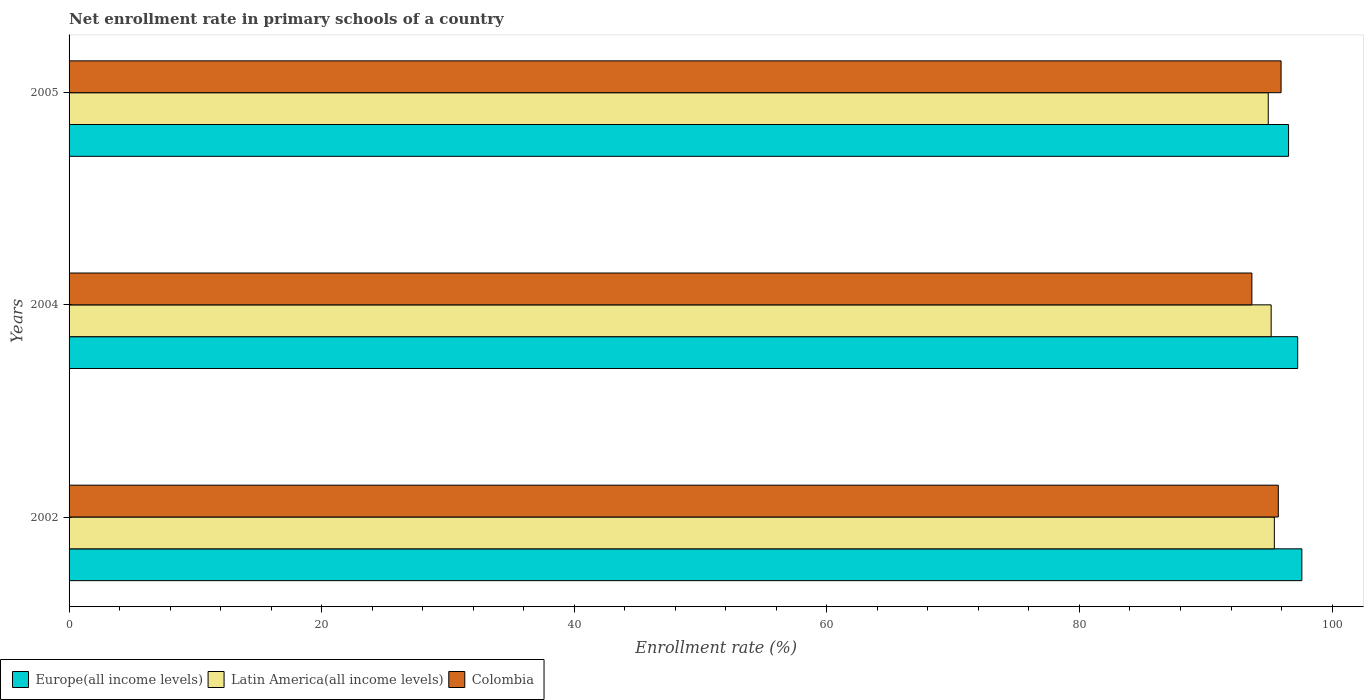How many different coloured bars are there?
Your answer should be compact. 3. Are the number of bars per tick equal to the number of legend labels?
Keep it short and to the point. Yes. How many bars are there on the 2nd tick from the bottom?
Your answer should be very brief. 3. What is the enrollment rate in primary schools in Europe(all income levels) in 2005?
Give a very brief answer. 96.56. Across all years, what is the maximum enrollment rate in primary schools in Europe(all income levels)?
Ensure brevity in your answer.  97.61. Across all years, what is the minimum enrollment rate in primary schools in Europe(all income levels)?
Keep it short and to the point. 96.56. In which year was the enrollment rate in primary schools in Latin America(all income levels) minimum?
Provide a succinct answer. 2005. What is the total enrollment rate in primary schools in Europe(all income levels) in the graph?
Your response must be concise. 291.44. What is the difference between the enrollment rate in primary schools in Colombia in 2004 and that in 2005?
Keep it short and to the point. -2.31. What is the difference between the enrollment rate in primary schools in Colombia in 2005 and the enrollment rate in primary schools in Latin America(all income levels) in 2002?
Give a very brief answer. 0.53. What is the average enrollment rate in primary schools in Europe(all income levels) per year?
Provide a short and direct response. 97.15. In the year 2002, what is the difference between the enrollment rate in primary schools in Europe(all income levels) and enrollment rate in primary schools in Colombia?
Make the answer very short. 1.86. What is the ratio of the enrollment rate in primary schools in Colombia in 2004 to that in 2005?
Make the answer very short. 0.98. Is the enrollment rate in primary schools in Latin America(all income levels) in 2002 less than that in 2004?
Keep it short and to the point. No. Is the difference between the enrollment rate in primary schools in Europe(all income levels) in 2002 and 2004 greater than the difference between the enrollment rate in primary schools in Colombia in 2002 and 2004?
Provide a succinct answer. No. What is the difference between the highest and the second highest enrollment rate in primary schools in Colombia?
Your response must be concise. 0.22. What is the difference between the highest and the lowest enrollment rate in primary schools in Europe(all income levels)?
Your answer should be very brief. 1.05. In how many years, is the enrollment rate in primary schools in Latin America(all income levels) greater than the average enrollment rate in primary schools in Latin America(all income levels) taken over all years?
Keep it short and to the point. 1. Is the sum of the enrollment rate in primary schools in Europe(all income levels) in 2002 and 2005 greater than the maximum enrollment rate in primary schools in Latin America(all income levels) across all years?
Ensure brevity in your answer.  Yes. What does the 1st bar from the top in 2004 represents?
Your response must be concise. Colombia. Is it the case that in every year, the sum of the enrollment rate in primary schools in Latin America(all income levels) and enrollment rate in primary schools in Europe(all income levels) is greater than the enrollment rate in primary schools in Colombia?
Keep it short and to the point. Yes. How many bars are there?
Offer a very short reply. 9. What is the difference between two consecutive major ticks on the X-axis?
Offer a terse response. 20. Are the values on the major ticks of X-axis written in scientific E-notation?
Ensure brevity in your answer.  No. How many legend labels are there?
Ensure brevity in your answer.  3. How are the legend labels stacked?
Provide a succinct answer. Horizontal. What is the title of the graph?
Give a very brief answer. Net enrollment rate in primary schools of a country. Does "Australia" appear as one of the legend labels in the graph?
Your response must be concise. No. What is the label or title of the X-axis?
Keep it short and to the point. Enrollment rate (%). What is the label or title of the Y-axis?
Offer a very short reply. Years. What is the Enrollment rate (%) of Europe(all income levels) in 2002?
Give a very brief answer. 97.61. What is the Enrollment rate (%) in Latin America(all income levels) in 2002?
Your answer should be very brief. 95.43. What is the Enrollment rate (%) in Colombia in 2002?
Provide a succinct answer. 95.74. What is the Enrollment rate (%) of Europe(all income levels) in 2004?
Ensure brevity in your answer.  97.28. What is the Enrollment rate (%) in Latin America(all income levels) in 2004?
Make the answer very short. 95.18. What is the Enrollment rate (%) in Colombia in 2004?
Give a very brief answer. 93.65. What is the Enrollment rate (%) of Europe(all income levels) in 2005?
Provide a succinct answer. 96.56. What is the Enrollment rate (%) of Latin America(all income levels) in 2005?
Your answer should be very brief. 94.95. What is the Enrollment rate (%) in Colombia in 2005?
Offer a very short reply. 95.96. Across all years, what is the maximum Enrollment rate (%) of Europe(all income levels)?
Your response must be concise. 97.61. Across all years, what is the maximum Enrollment rate (%) of Latin America(all income levels)?
Offer a terse response. 95.43. Across all years, what is the maximum Enrollment rate (%) of Colombia?
Your answer should be very brief. 95.96. Across all years, what is the minimum Enrollment rate (%) of Europe(all income levels)?
Make the answer very short. 96.56. Across all years, what is the minimum Enrollment rate (%) of Latin America(all income levels)?
Provide a succinct answer. 94.95. Across all years, what is the minimum Enrollment rate (%) in Colombia?
Your response must be concise. 93.65. What is the total Enrollment rate (%) in Europe(all income levels) in the graph?
Offer a very short reply. 291.44. What is the total Enrollment rate (%) in Latin America(all income levels) in the graph?
Offer a very short reply. 285.56. What is the total Enrollment rate (%) of Colombia in the graph?
Provide a short and direct response. 285.36. What is the difference between the Enrollment rate (%) in Europe(all income levels) in 2002 and that in 2004?
Provide a short and direct response. 0.33. What is the difference between the Enrollment rate (%) in Latin America(all income levels) in 2002 and that in 2004?
Give a very brief answer. 0.25. What is the difference between the Enrollment rate (%) in Colombia in 2002 and that in 2004?
Your response must be concise. 2.09. What is the difference between the Enrollment rate (%) in Europe(all income levels) in 2002 and that in 2005?
Provide a short and direct response. 1.05. What is the difference between the Enrollment rate (%) of Latin America(all income levels) in 2002 and that in 2005?
Offer a terse response. 0.48. What is the difference between the Enrollment rate (%) in Colombia in 2002 and that in 2005?
Ensure brevity in your answer.  -0.22. What is the difference between the Enrollment rate (%) in Europe(all income levels) in 2004 and that in 2005?
Ensure brevity in your answer.  0.72. What is the difference between the Enrollment rate (%) of Latin America(all income levels) in 2004 and that in 2005?
Your response must be concise. 0.23. What is the difference between the Enrollment rate (%) of Colombia in 2004 and that in 2005?
Your answer should be compact. -2.31. What is the difference between the Enrollment rate (%) of Europe(all income levels) in 2002 and the Enrollment rate (%) of Latin America(all income levels) in 2004?
Your answer should be very brief. 2.43. What is the difference between the Enrollment rate (%) of Europe(all income levels) in 2002 and the Enrollment rate (%) of Colombia in 2004?
Provide a short and direct response. 3.96. What is the difference between the Enrollment rate (%) in Latin America(all income levels) in 2002 and the Enrollment rate (%) in Colombia in 2004?
Make the answer very short. 1.78. What is the difference between the Enrollment rate (%) of Europe(all income levels) in 2002 and the Enrollment rate (%) of Latin America(all income levels) in 2005?
Provide a succinct answer. 2.66. What is the difference between the Enrollment rate (%) in Europe(all income levels) in 2002 and the Enrollment rate (%) in Colombia in 2005?
Give a very brief answer. 1.64. What is the difference between the Enrollment rate (%) in Latin America(all income levels) in 2002 and the Enrollment rate (%) in Colombia in 2005?
Your answer should be very brief. -0.53. What is the difference between the Enrollment rate (%) of Europe(all income levels) in 2004 and the Enrollment rate (%) of Latin America(all income levels) in 2005?
Provide a succinct answer. 2.33. What is the difference between the Enrollment rate (%) in Europe(all income levels) in 2004 and the Enrollment rate (%) in Colombia in 2005?
Offer a very short reply. 1.32. What is the difference between the Enrollment rate (%) of Latin America(all income levels) in 2004 and the Enrollment rate (%) of Colombia in 2005?
Your answer should be very brief. -0.79. What is the average Enrollment rate (%) of Europe(all income levels) per year?
Offer a very short reply. 97.15. What is the average Enrollment rate (%) of Latin America(all income levels) per year?
Your response must be concise. 95.19. What is the average Enrollment rate (%) of Colombia per year?
Keep it short and to the point. 95.12. In the year 2002, what is the difference between the Enrollment rate (%) of Europe(all income levels) and Enrollment rate (%) of Latin America(all income levels)?
Your answer should be very brief. 2.18. In the year 2002, what is the difference between the Enrollment rate (%) in Europe(all income levels) and Enrollment rate (%) in Colombia?
Provide a short and direct response. 1.86. In the year 2002, what is the difference between the Enrollment rate (%) of Latin America(all income levels) and Enrollment rate (%) of Colombia?
Your answer should be very brief. -0.31. In the year 2004, what is the difference between the Enrollment rate (%) in Europe(all income levels) and Enrollment rate (%) in Latin America(all income levels)?
Your answer should be compact. 2.1. In the year 2004, what is the difference between the Enrollment rate (%) of Europe(all income levels) and Enrollment rate (%) of Colombia?
Keep it short and to the point. 3.63. In the year 2004, what is the difference between the Enrollment rate (%) of Latin America(all income levels) and Enrollment rate (%) of Colombia?
Make the answer very short. 1.52. In the year 2005, what is the difference between the Enrollment rate (%) in Europe(all income levels) and Enrollment rate (%) in Latin America(all income levels)?
Your answer should be very brief. 1.61. In the year 2005, what is the difference between the Enrollment rate (%) in Europe(all income levels) and Enrollment rate (%) in Colombia?
Offer a terse response. 0.59. In the year 2005, what is the difference between the Enrollment rate (%) in Latin America(all income levels) and Enrollment rate (%) in Colombia?
Keep it short and to the point. -1.02. What is the ratio of the Enrollment rate (%) of Europe(all income levels) in 2002 to that in 2004?
Your response must be concise. 1. What is the ratio of the Enrollment rate (%) of Colombia in 2002 to that in 2004?
Give a very brief answer. 1.02. What is the ratio of the Enrollment rate (%) of Europe(all income levels) in 2002 to that in 2005?
Offer a very short reply. 1.01. What is the ratio of the Enrollment rate (%) in Colombia in 2002 to that in 2005?
Make the answer very short. 1. What is the ratio of the Enrollment rate (%) of Europe(all income levels) in 2004 to that in 2005?
Ensure brevity in your answer.  1.01. What is the ratio of the Enrollment rate (%) of Latin America(all income levels) in 2004 to that in 2005?
Your answer should be compact. 1. What is the ratio of the Enrollment rate (%) in Colombia in 2004 to that in 2005?
Your response must be concise. 0.98. What is the difference between the highest and the second highest Enrollment rate (%) in Europe(all income levels)?
Your answer should be very brief. 0.33. What is the difference between the highest and the second highest Enrollment rate (%) in Latin America(all income levels)?
Give a very brief answer. 0.25. What is the difference between the highest and the second highest Enrollment rate (%) in Colombia?
Offer a very short reply. 0.22. What is the difference between the highest and the lowest Enrollment rate (%) of Europe(all income levels)?
Provide a succinct answer. 1.05. What is the difference between the highest and the lowest Enrollment rate (%) in Latin America(all income levels)?
Offer a terse response. 0.48. What is the difference between the highest and the lowest Enrollment rate (%) of Colombia?
Keep it short and to the point. 2.31. 